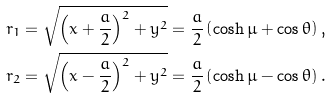Convert formula to latex. <formula><loc_0><loc_0><loc_500><loc_500>r _ { 1 } & = \sqrt { \left ( x + \frac { a } { 2 } \right ) ^ { 2 } + y ^ { 2 } } = \frac { a } { 2 } \left ( \cosh \mu + \cos \theta \right ) \text {,} \\ r _ { 2 } & = \sqrt { \left ( x - \frac { a } { 2 } \right ) ^ { 2 } + y ^ { 2 } } = \frac { a } { 2 } \left ( \cosh \mu - \cos \theta \right ) .</formula> 